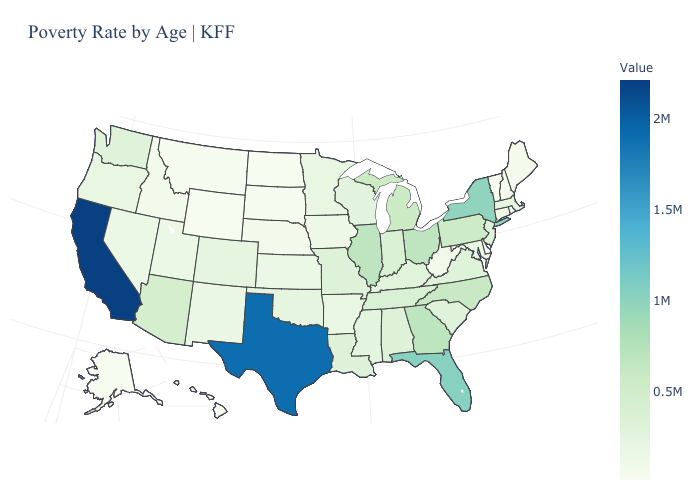Does Montana have the highest value in the USA?
Answer briefly. No. Does Kentucky have the highest value in the USA?
Concise answer only. No. Among the states that border Illinois , does Iowa have the highest value?
Answer briefly. No. Among the states that border Rhode Island , which have the lowest value?
Answer briefly. Connecticut. Among the states that border Maryland , does Delaware have the lowest value?
Be succinct. Yes. Which states hav the highest value in the South?
Quick response, please. Texas. 